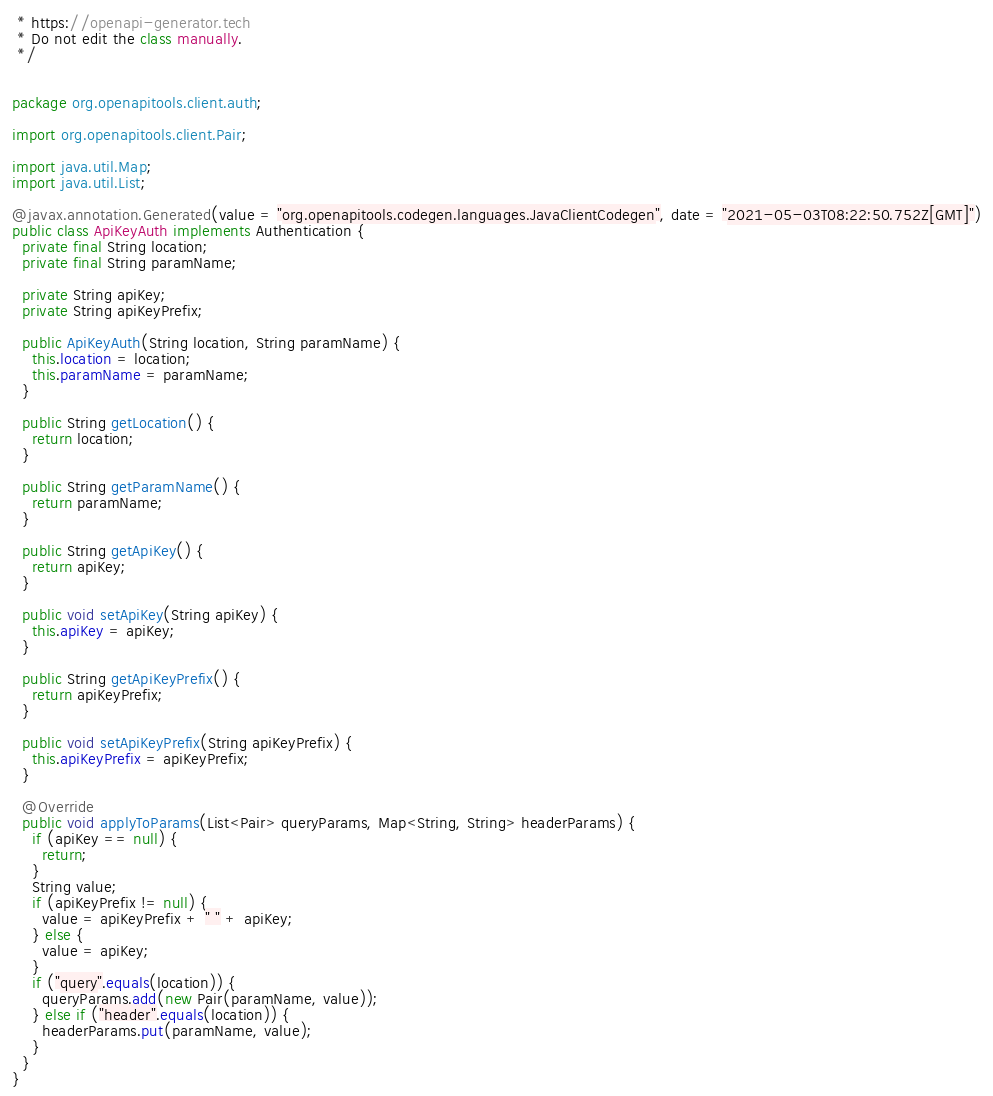Convert code to text. <code><loc_0><loc_0><loc_500><loc_500><_Java_> * https://openapi-generator.tech
 * Do not edit the class manually.
 */


package org.openapitools.client.auth;

import org.openapitools.client.Pair;

import java.util.Map;
import java.util.List;

@javax.annotation.Generated(value = "org.openapitools.codegen.languages.JavaClientCodegen", date = "2021-05-03T08:22:50.752Z[GMT]")
public class ApiKeyAuth implements Authentication {
  private final String location;
  private final String paramName;

  private String apiKey;
  private String apiKeyPrefix;

  public ApiKeyAuth(String location, String paramName) {
    this.location = location;
    this.paramName = paramName;
  }

  public String getLocation() {
    return location;
  }

  public String getParamName() {
    return paramName;
  }

  public String getApiKey() {
    return apiKey;
  }

  public void setApiKey(String apiKey) {
    this.apiKey = apiKey;
  }

  public String getApiKeyPrefix() {
    return apiKeyPrefix;
  }

  public void setApiKeyPrefix(String apiKeyPrefix) {
    this.apiKeyPrefix = apiKeyPrefix;
  }

  @Override
  public void applyToParams(List<Pair> queryParams, Map<String, String> headerParams) {
    if (apiKey == null) {
      return;
    }
    String value;
    if (apiKeyPrefix != null) {
      value = apiKeyPrefix + " " + apiKey;
    } else {
      value = apiKey;
    }
    if ("query".equals(location)) {
      queryParams.add(new Pair(paramName, value));
    } else if ("header".equals(location)) {
      headerParams.put(paramName, value);
    }
  }
}
</code> 